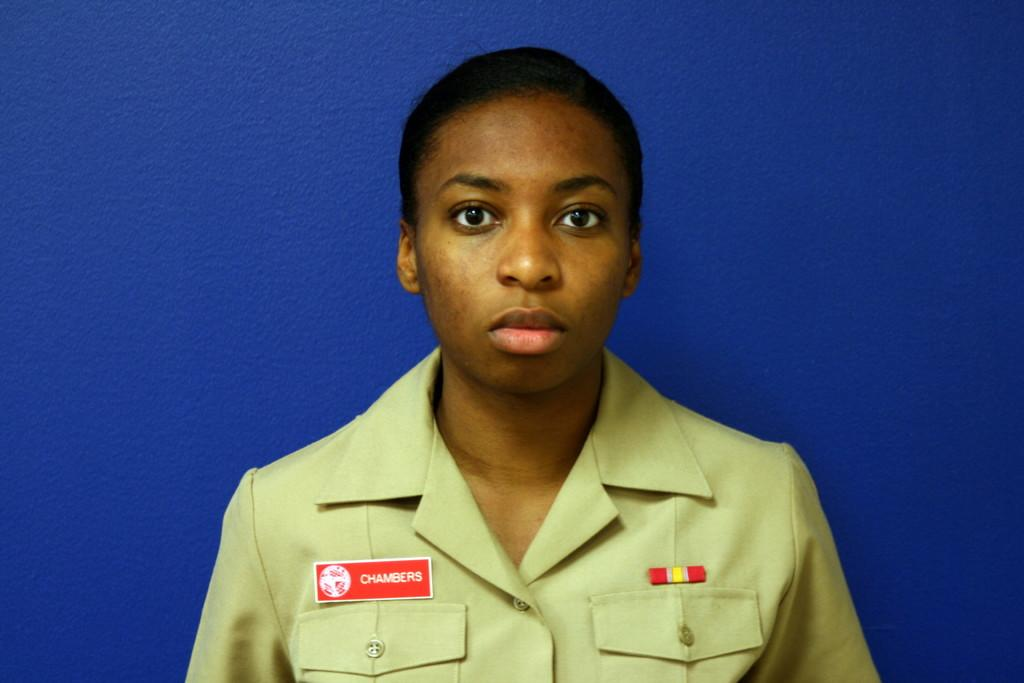Who is present in the image? There is a woman in the image. What is the woman doing in the image? The woman is watching something. Can you describe the woman's clothing? There is a batch on her shirt. What can be seen in the background of the image? The background of the image has a blue surface. Where is the store located in the image? There is no store present in the image. Can you see any fangs on the woman in the image? There are no fangs visible on the woman in the image. 